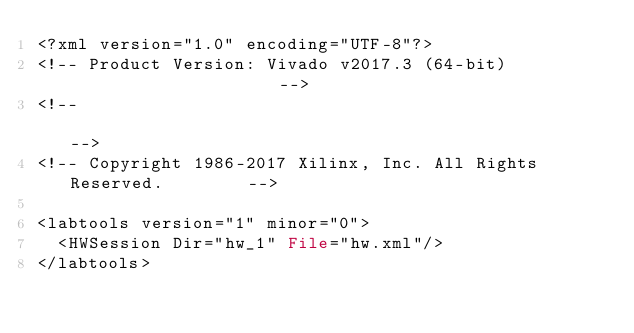<code> <loc_0><loc_0><loc_500><loc_500><_Pascal_><?xml version="1.0" encoding="UTF-8"?>
<!-- Product Version: Vivado v2017.3 (64-bit)                     -->
<!--                                                              -->
<!-- Copyright 1986-2017 Xilinx, Inc. All Rights Reserved.        -->

<labtools version="1" minor="0">
  <HWSession Dir="hw_1" File="hw.xml"/>
</labtools>
</code> 